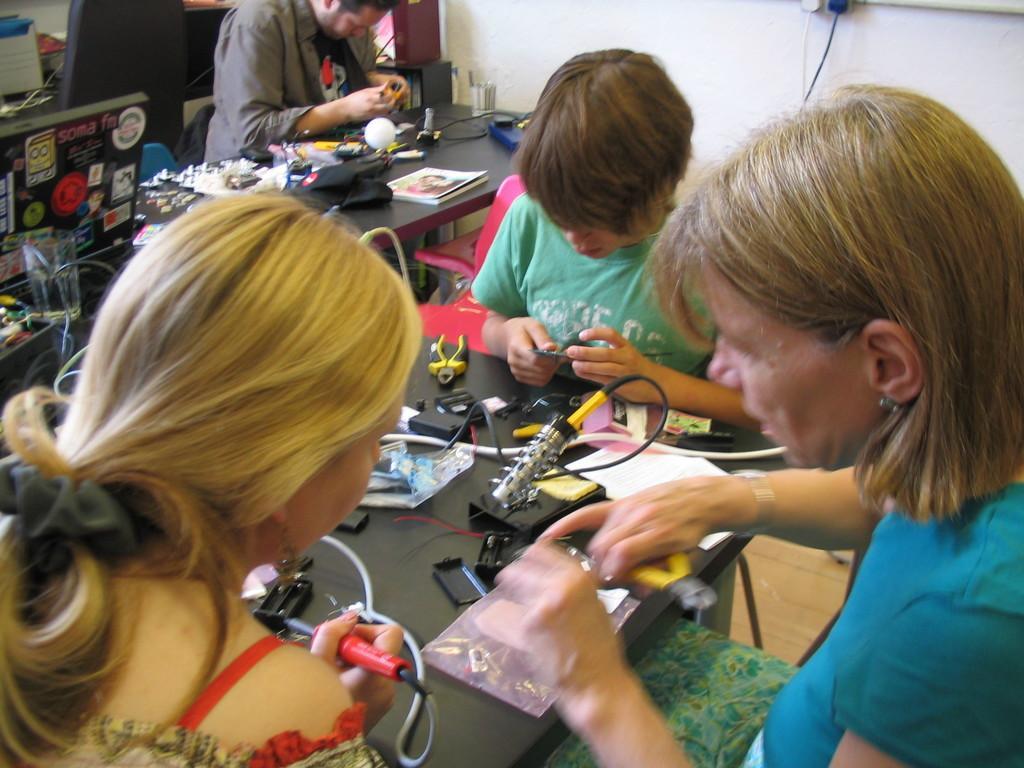Describe this image in one or two sentences. Here we can see four persons sitting on the chair at the table. On the table we can see electrical items,cutting pliers,books,cables,monitor,glass and some other items. In the background there is a wall,cables and floor. 